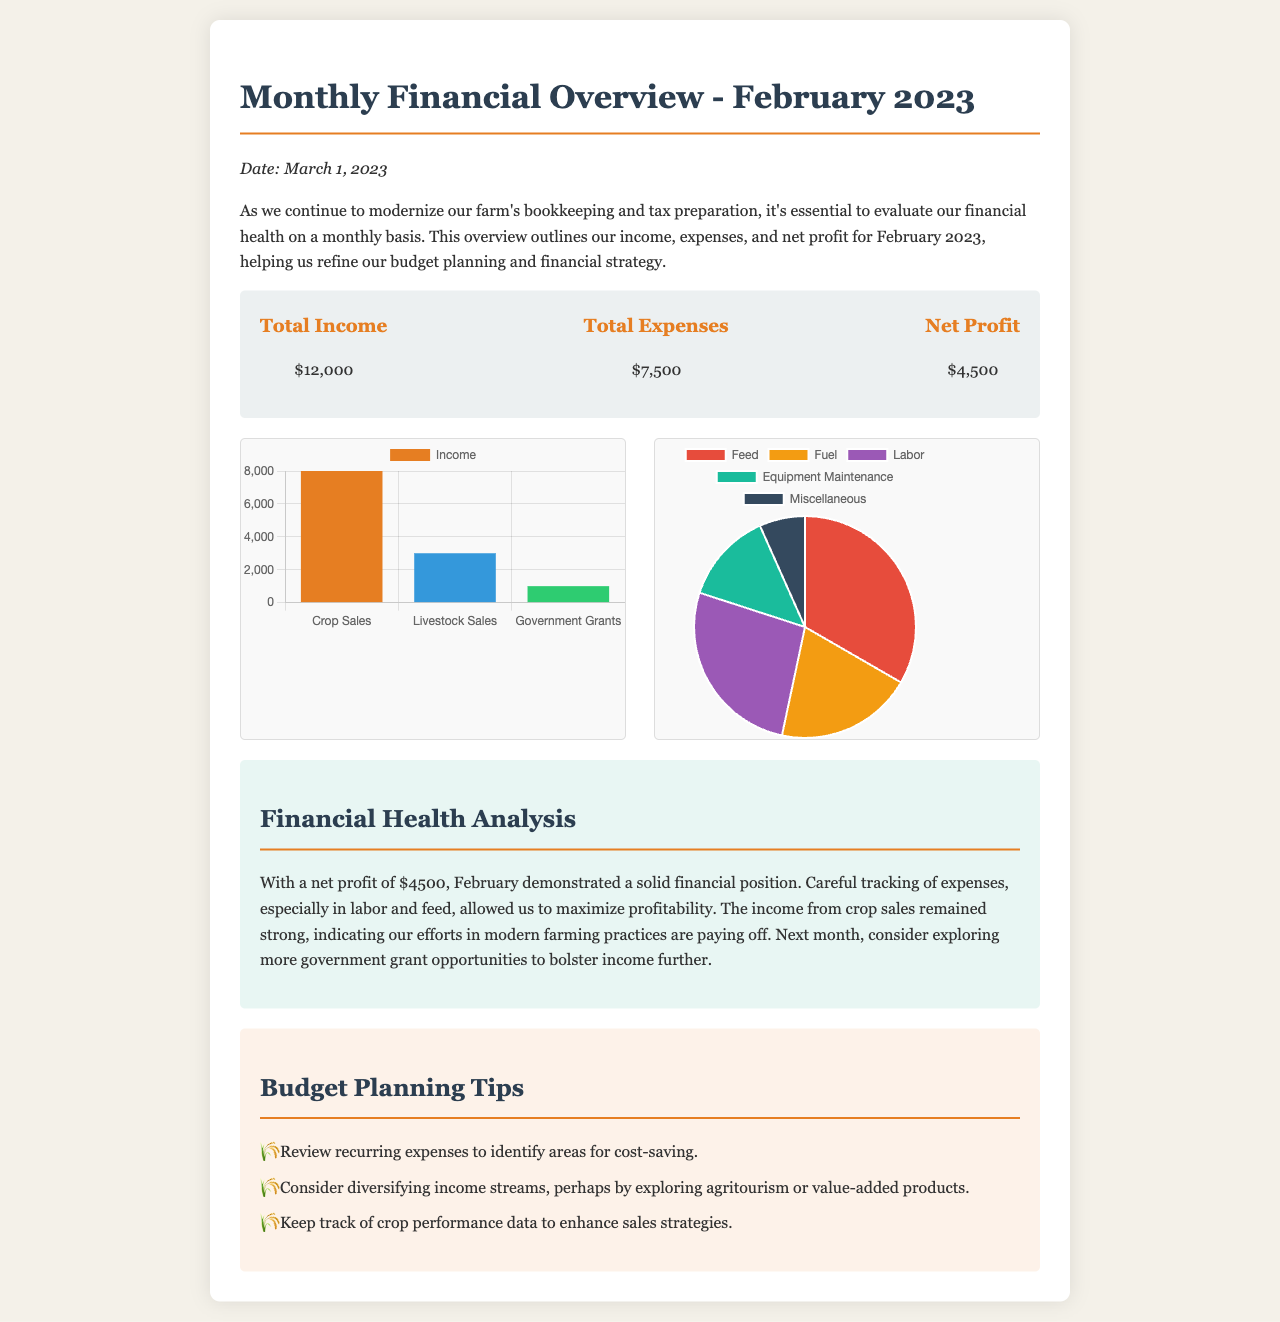what was the total income for February 2023? The total income is explicitly stated in the summary section of the document as $12,000.
Answer: $12,000 what were the total expenses for February 2023? The total expenses are provided in the summary section of the document as $7,500.
Answer: $7,500 what is the net profit for February 2023? The net profit is calculated as Total Income - Total Expenses, shown in the summary as $4,500.
Answer: $4,500 which income category contributed the most to total income? The income chart outlines that crop sales contributed $8,000, which is more than any other income source.
Answer: Crop Sales which expense category had the highest cost? The expense chart shows that labor costs amount to $2,000, which is the highest among the categories listed.
Answer: Labor what financial position did February demonstrate? The document explicitly mentions that February demonstrated a solid financial position based on the net profit achieved.
Answer: Solid what budget planning tip suggests exploring new income sources? The tip recommends considering diversifying income streams, which includes exploring agritourism.
Answer: Diversifying income streams what type of chart represents the income breakdown? The income breakdown is represented through a bar chart format, as noted in the document.
Answer: Bar chart what was the publication date of the financial overview? The document states that the financial overview was published on March 1, 2023.
Answer: March 1, 2023 